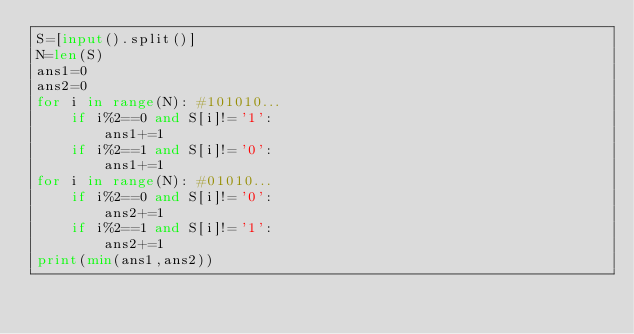Convert code to text. <code><loc_0><loc_0><loc_500><loc_500><_Python_>S=[input().split()]
N=len(S)
ans1=0
ans2=0
for i in range(N): #101010...
    if i%2==0 and S[i]!='1':
        ans1+=1
    if i%2==1 and S[i]!='0':
        ans1+=1
for i in range(N): #01010...
    if i%2==0 and S[i]!='0':
        ans2+=1
    if i%2==1 and S[i]!='1':
        ans2+=1
print(min(ans1,ans2))</code> 